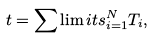Convert formula to latex. <formula><loc_0><loc_0><loc_500><loc_500>t = \sum \lim i t s _ { i = 1 } ^ { N } T _ { i } ,</formula> 